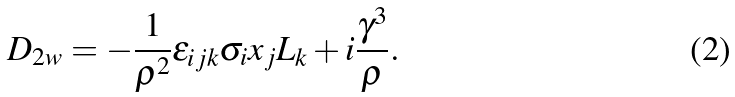Convert formula to latex. <formula><loc_0><loc_0><loc_500><loc_500>D _ { 2 w } = - \frac { 1 } { \rho ^ { 2 } } \epsilon _ { i j k } \sigma _ { i } x _ { j } L _ { k } + i \frac { \gamma ^ { 3 } } { \rho } .</formula> 